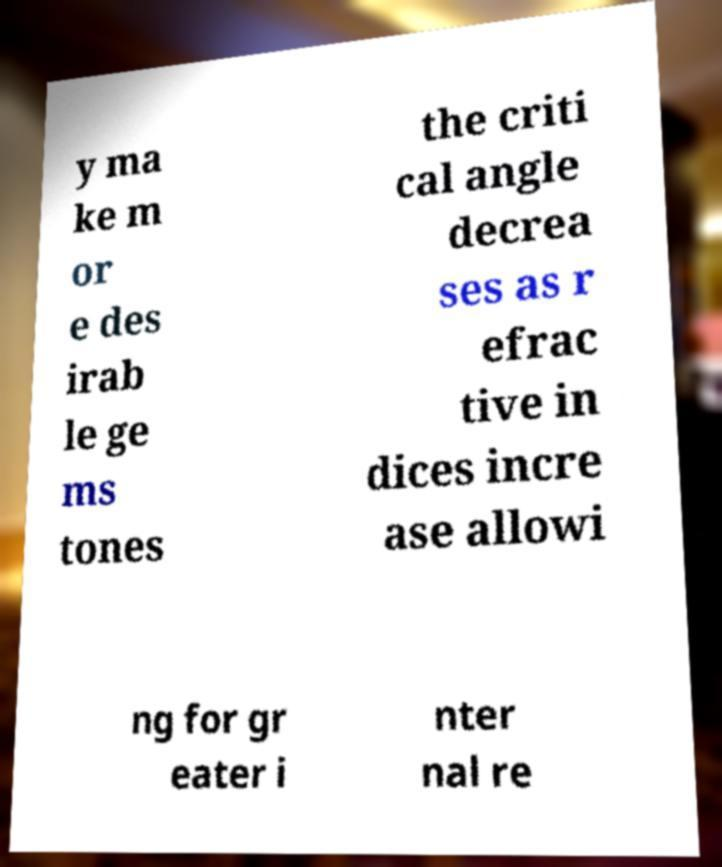Please read and relay the text visible in this image. What does it say? y ma ke m or e des irab le ge ms tones the criti cal angle decrea ses as r efrac tive in dices incre ase allowi ng for gr eater i nter nal re 